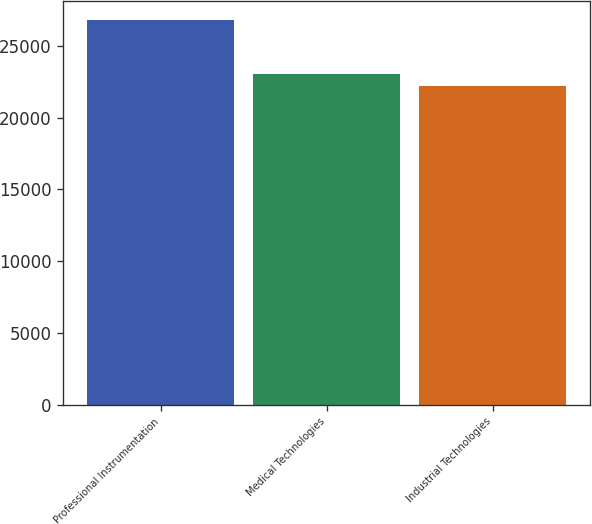Convert chart. <chart><loc_0><loc_0><loc_500><loc_500><bar_chart><fcel>Professional Instrumentation<fcel>Medical Technologies<fcel>Industrial Technologies<nl><fcel>26786<fcel>23047<fcel>22199<nl></chart> 